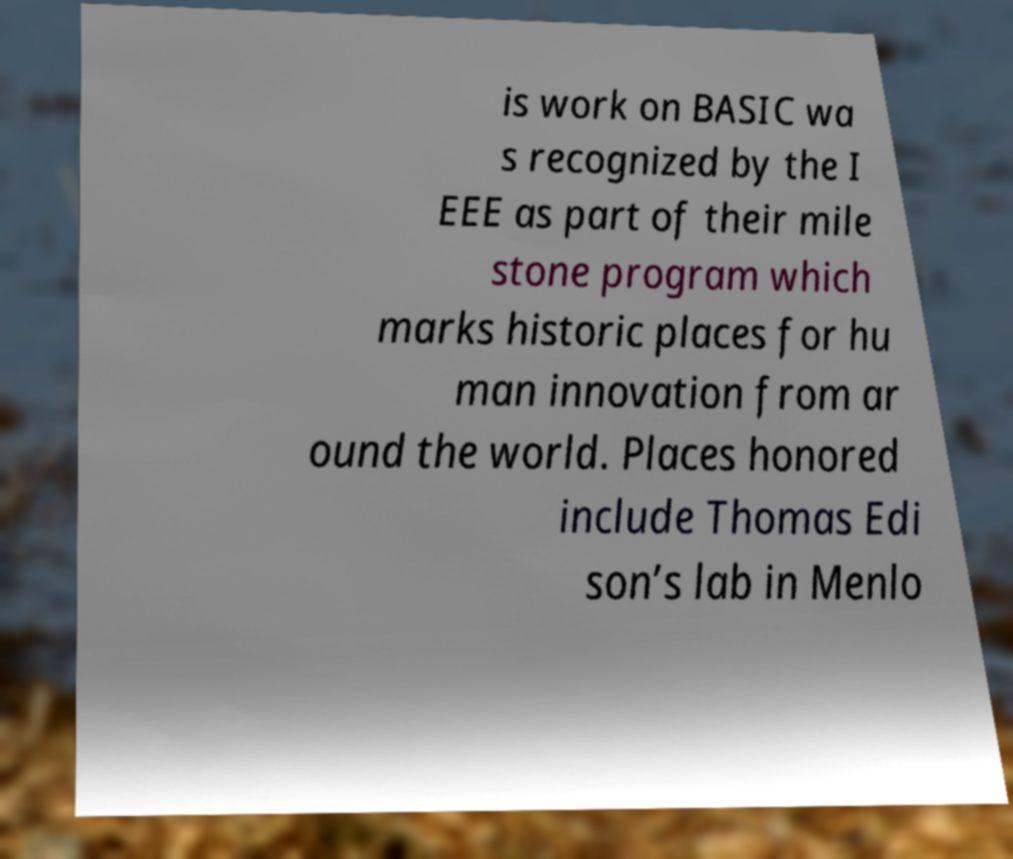What messages or text are displayed in this image? I need them in a readable, typed format. is work on BASIC wa s recognized by the I EEE as part of their mile stone program which marks historic places for hu man innovation from ar ound the world. Places honored include Thomas Edi son’s lab in Menlo 